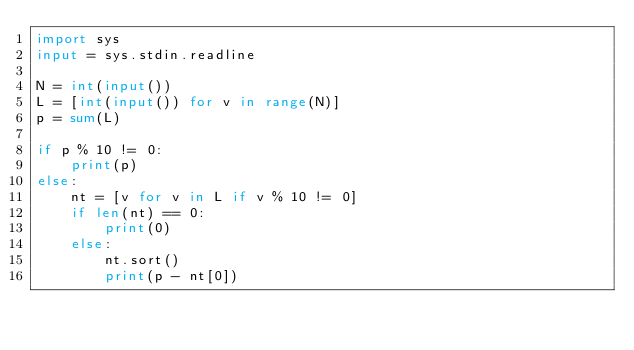<code> <loc_0><loc_0><loc_500><loc_500><_Python_>import sys
input = sys.stdin.readline

N = int(input())
L = [int(input()) for v in range(N)]
p = sum(L)

if p % 10 != 0:
    print(p)
else:
    nt = [v for v in L if v % 10 != 0]
    if len(nt) == 0:
        print(0)
    else:
        nt.sort()
        print(p - nt[0])</code> 